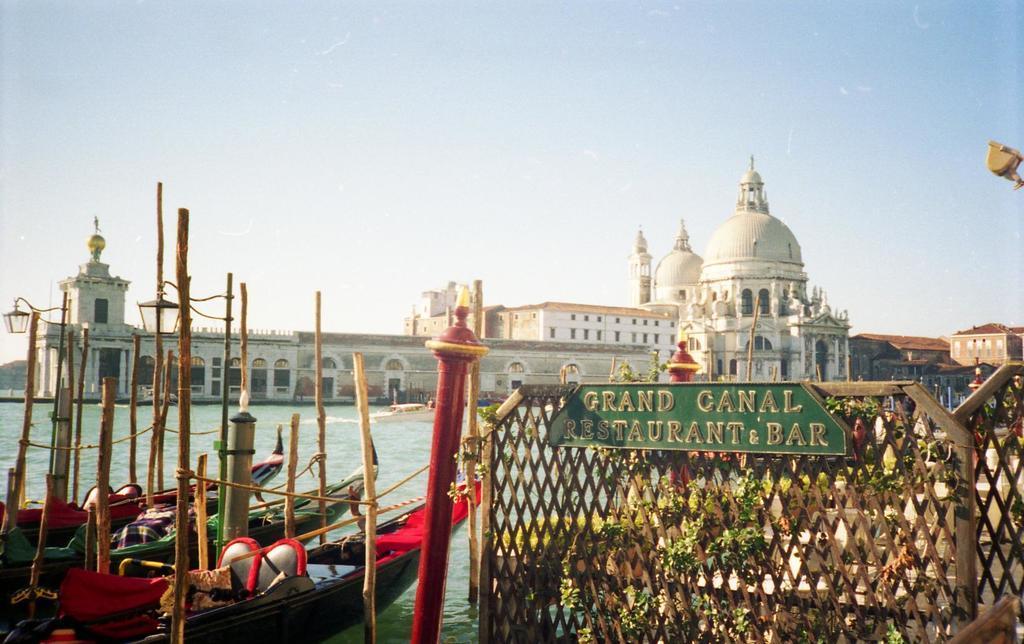In one or two sentences, can you explain what this image depicts? In this image there are buildings and we can see a fence. There is a board. We can see water and there are boats on the water. In the background there is sky. There are plants. 